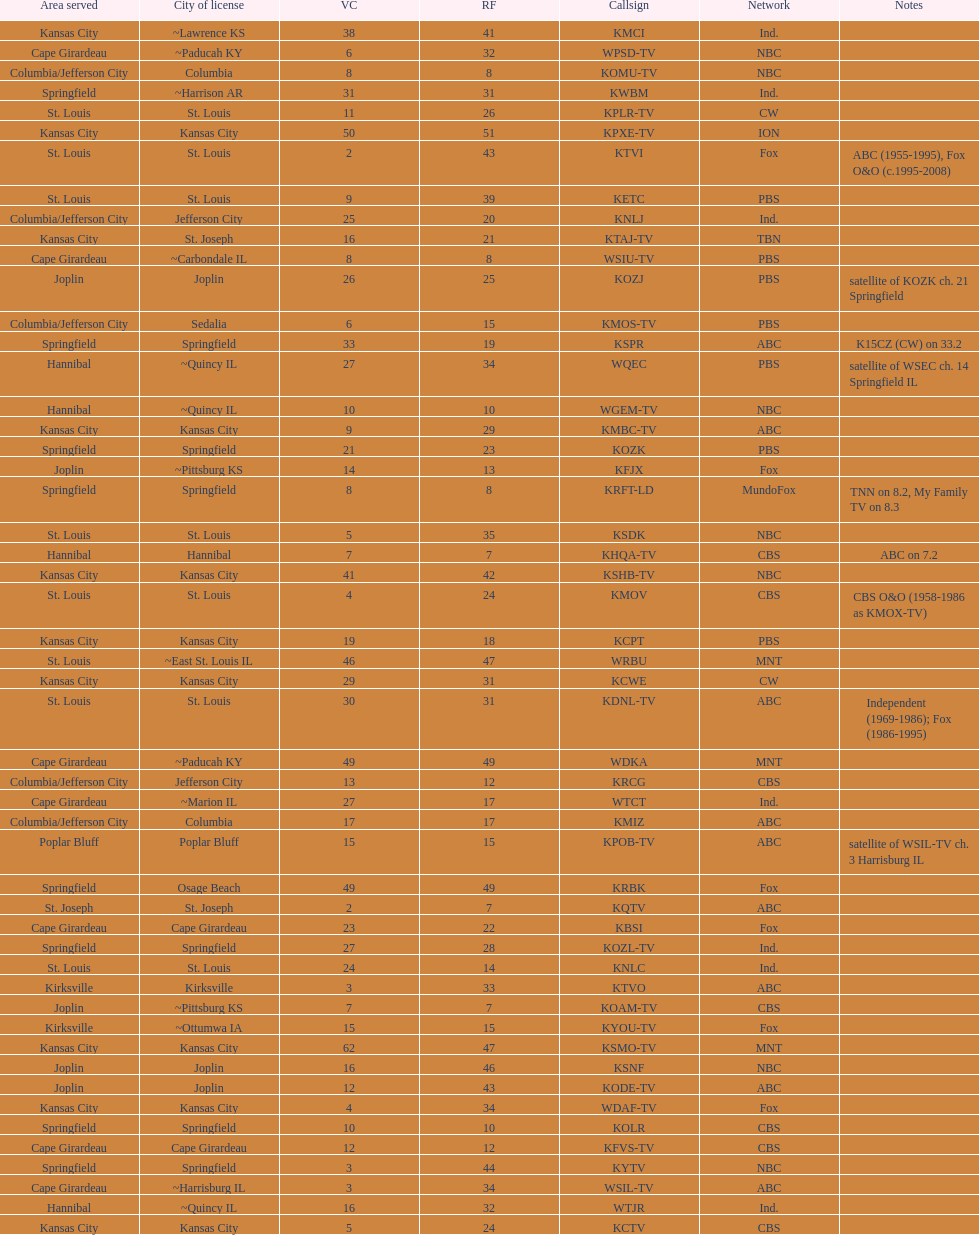What is the total number of stations under the cbs network? 7. 